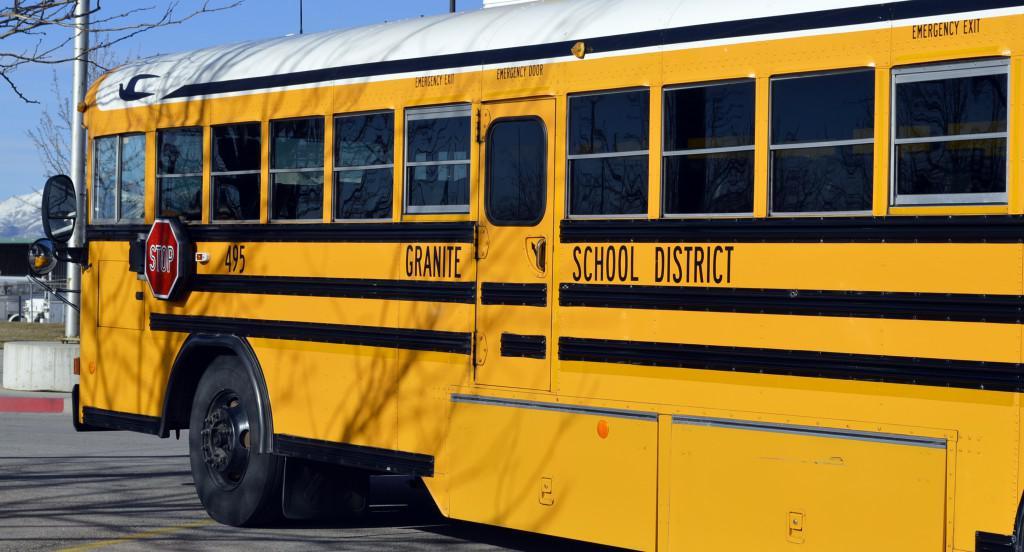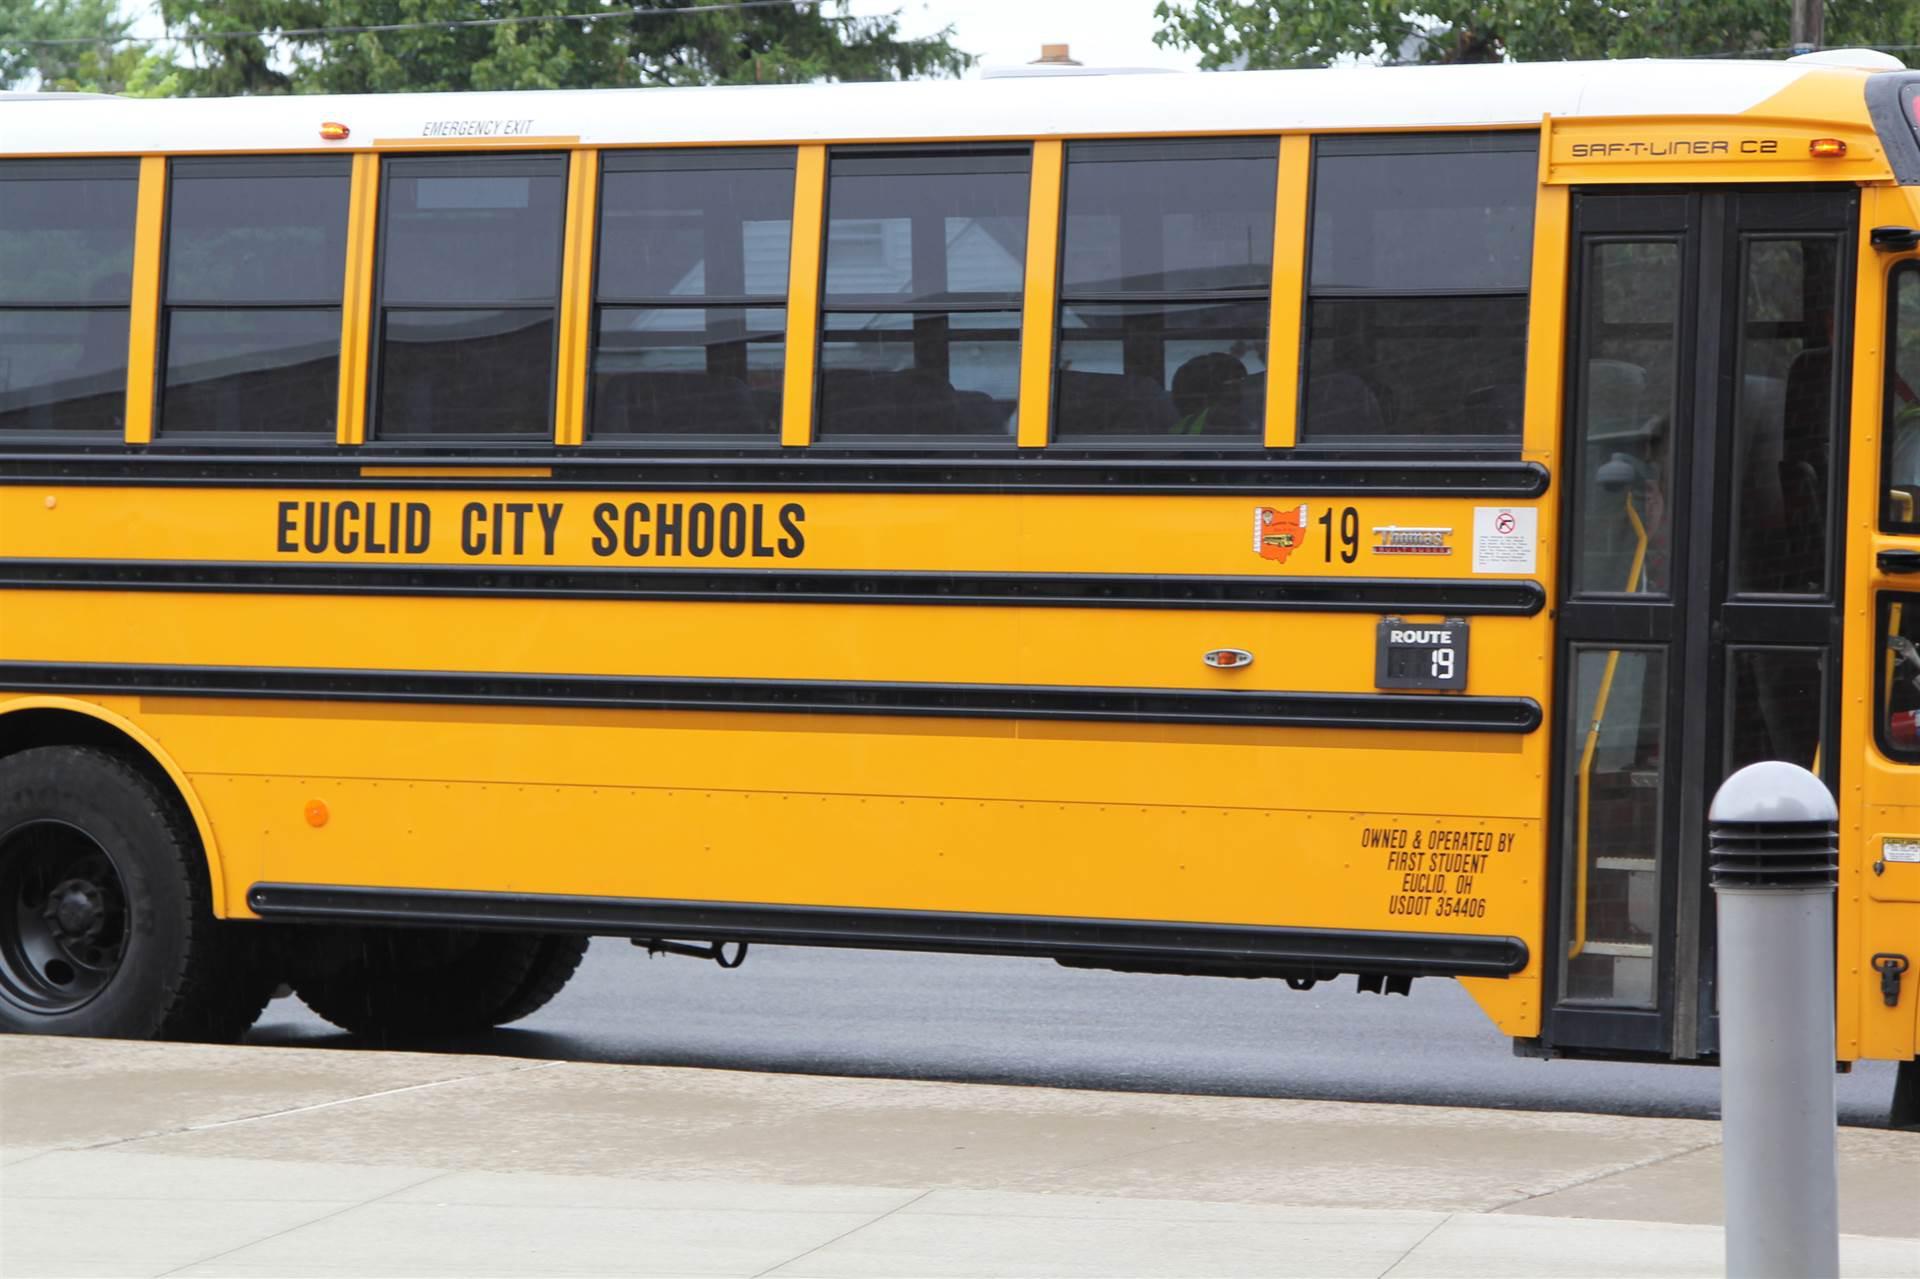The first image is the image on the left, the second image is the image on the right. For the images shown, is this caption "There are more buses in the right image than in the left image." true? Answer yes or no. No. The first image is the image on the left, the second image is the image on the right. For the images shown, is this caption "An image shows one horizontal bus with closed passenger doors at the right." true? Answer yes or no. Yes. 